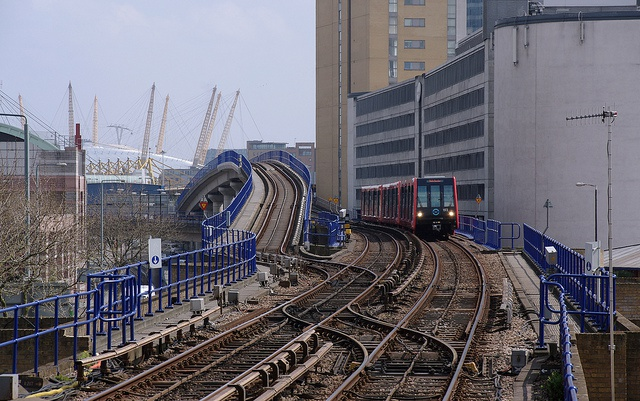Describe the objects in this image and their specific colors. I can see a train in lavender, black, gray, and maroon tones in this image. 